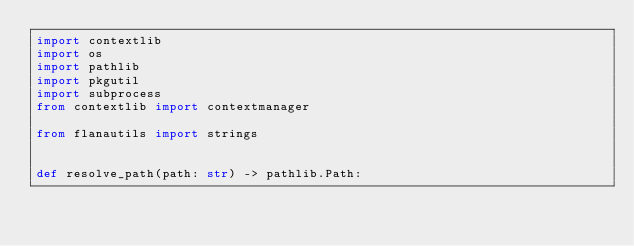Convert code to text. <code><loc_0><loc_0><loc_500><loc_500><_Python_>import contextlib
import os
import pathlib
import pkgutil
import subprocess
from contextlib import contextmanager

from flanautils import strings


def resolve_path(path: str) -> pathlib.Path:</code> 